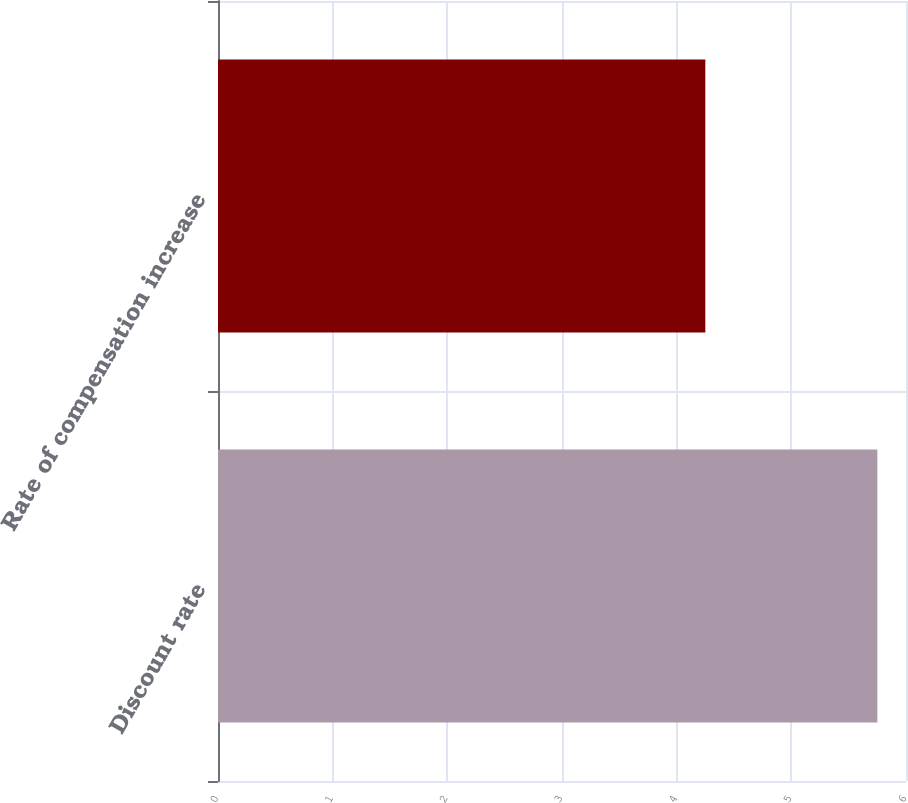Convert chart to OTSL. <chart><loc_0><loc_0><loc_500><loc_500><bar_chart><fcel>Discount rate<fcel>Rate of compensation increase<nl><fcel>5.75<fcel>4.25<nl></chart> 